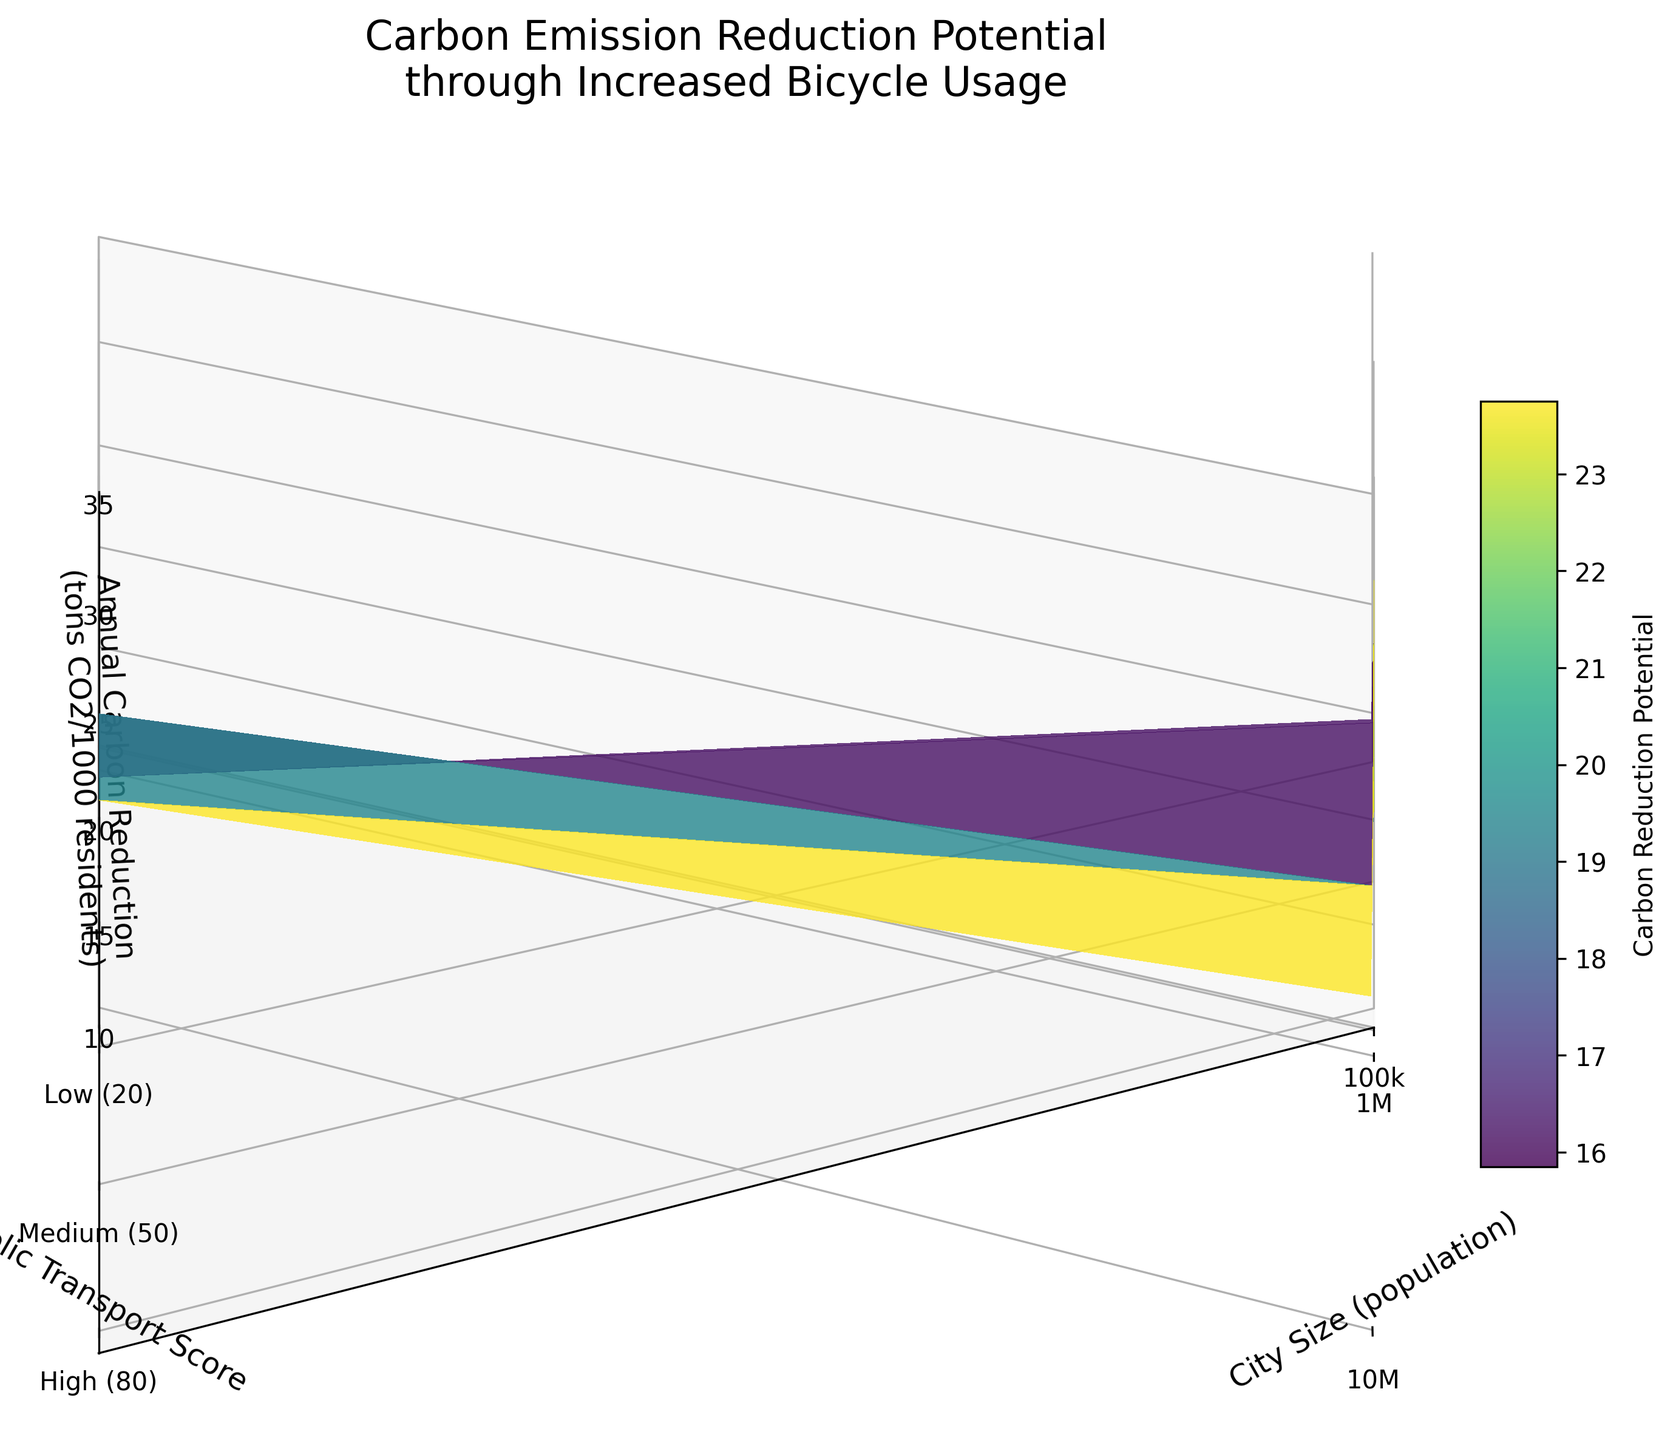What is the title of the 3D surface plot? The title is usually located at the top of the plot in larger font size than the other text.
Answer: Carbon Emission Reduction Potential through Increased Bicycle Usage What are the labels for the x-axis, y-axis, and z-axis? The axis labels describe the parameters being measured along each axis. For the x-axis, it is "City Size (population)," for the y-axis, it is "Public Transport Score," and for the z-axis, it is "Annual Carbon Reduction (tons CO2/1000 residents)."
Answer: City Size (population), Public Transport Score, Annual Carbon Reduction (tons CO2/1000 residents) What is the least amount of carbon reduction seen in the plot, and for which combination of city size and public transport score does it occur? By observing the z-axis, the lowest value, which is 10.5 tons CO2/1000 residents, occurs at the public transport score of 80 in cities with a population of 100,000.
Answer: 10.5 tons CO2/1000 residents at 100000 population and 80 public transport score How is the annual carbon reduction affected by increasing city size while keeping the public transport score constant at 20? Observing the z-axis values along the x-axis for a fixed y-axis value of 20, you can see they increase from 15.2 to 31.5 tons CO2/1000 residents as city size increases from 100,000 to 10,000,000.
Answer: It increases from 15.2 to 31.5 tons CO2/1000 residents Is there a trend between the public transport score and carbon reduction in a city with a population of 1,000,000? For 1,000,000, select points on the z-axis based on the y-axis (public transport score). You can observe a decreasing trend as the public transport score increases from 20 to 80.
Answer: The carbon reduction decreases What is the approximate difference in annual carbon reduction between cities with populations of 5,000,000 and 1,000,000, when the public transport score is 50? For a public transport score of 50, the carbon reduction values at populations 5,000,000 and 1,000,000 are 23.2 and 19.1, respectively. The difference is 23.2 - 19.1 = 4.1 tons CO2/1000 residents.
Answer: 4.1 tons CO2/1000 residents Which city size and public transport score combination result in the highest annual carbon reduction? By examining the z-axis values, the highest carbon reduction is 31.5 tons CO2/1000 residents, which occurs at population 10,000,000 and a public transport score of 20.
Answer: 10,000,000 population and 20 public transport score Does the plot indicate that larger cities have more potential for carbon reduction through increased bicycle usage? Evaluating the plot along the x-axis (city size) indicates that larger cities result in higher z-axis values (carbon reduction), suggesting that larger cities have more potential for carbon reduction.
Answer: Yes How does the carbon reduction potential compare between low and high public transport scores for the largest city size? For the largest city size (10,000,000), examining the z-axis values for public transport scores of 20 and 80 indicates a difference from 31.5 to 24.3 tons CO2/1000 residents, showing a decrease.
Answer: It decreases from 31.5 to 24.3 tons CO2/1000 residents 